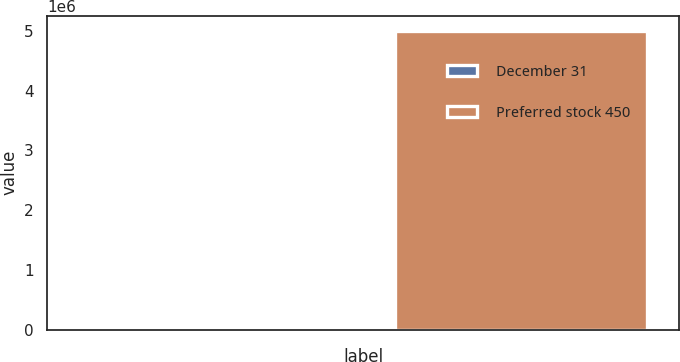<chart> <loc_0><loc_0><loc_500><loc_500><bar_chart><fcel>December 31<fcel>Preferred stock 450<nl><fcel>2007<fcel>5e+06<nl></chart> 